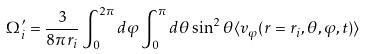<formula> <loc_0><loc_0><loc_500><loc_500>\Omega ^ { \prime } _ { i } = \frac { 3 } { 8 \pi r _ { i } } \int _ { 0 } ^ { 2 \pi } d \varphi \int _ { 0 } ^ { \pi } d \theta \sin ^ { 2 } \theta \langle v _ { \varphi } ( r = r _ { i } , \theta , \varphi , t ) \rangle</formula> 